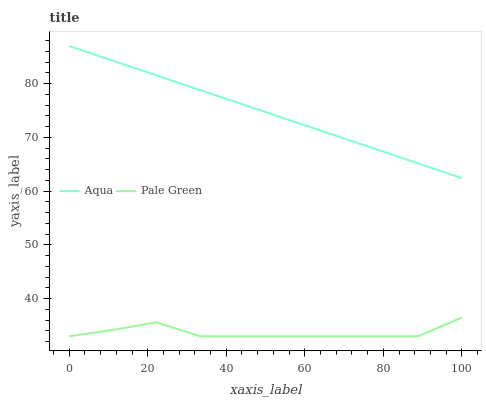Does Pale Green have the minimum area under the curve?
Answer yes or no. Yes. Does Aqua have the maximum area under the curve?
Answer yes or no. Yes. Does Aqua have the minimum area under the curve?
Answer yes or no. No. Is Aqua the smoothest?
Answer yes or no. Yes. Is Pale Green the roughest?
Answer yes or no. Yes. Is Aqua the roughest?
Answer yes or no. No. Does Pale Green have the lowest value?
Answer yes or no. Yes. Does Aqua have the lowest value?
Answer yes or no. No. Does Aqua have the highest value?
Answer yes or no. Yes. Is Pale Green less than Aqua?
Answer yes or no. Yes. Is Aqua greater than Pale Green?
Answer yes or no. Yes. Does Pale Green intersect Aqua?
Answer yes or no. No. 